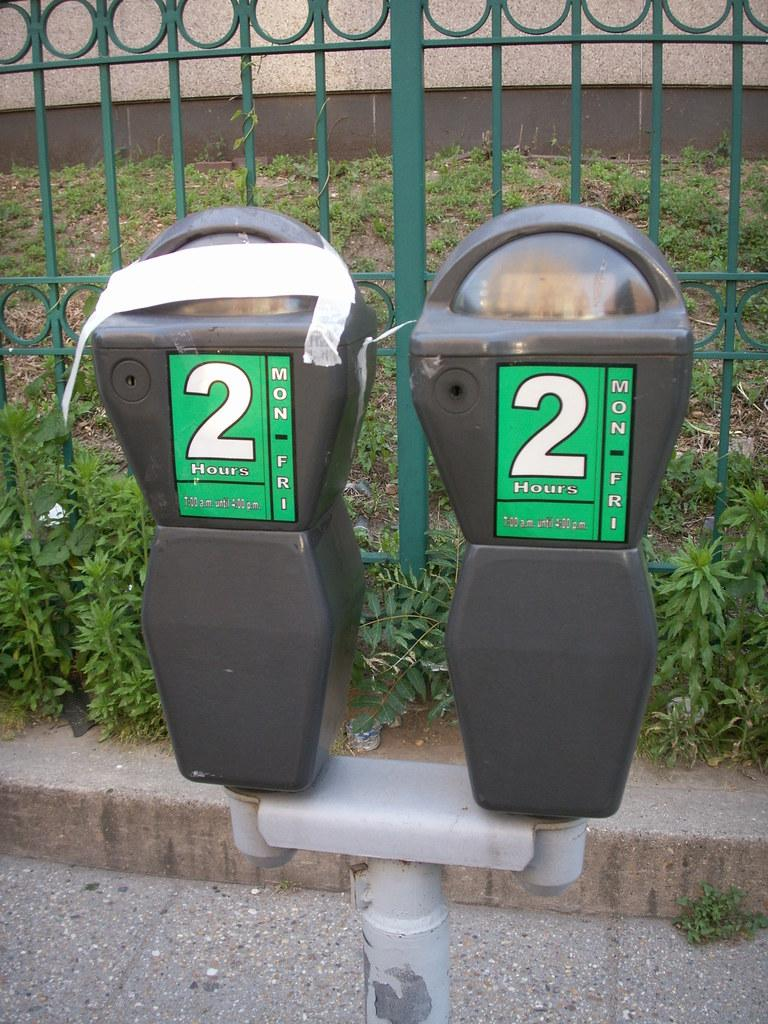<image>
Describe the image concisely. Two parking meters, one of which is broke and taped, that give the days Mon - Fri and the alloted time of 2 hours. 